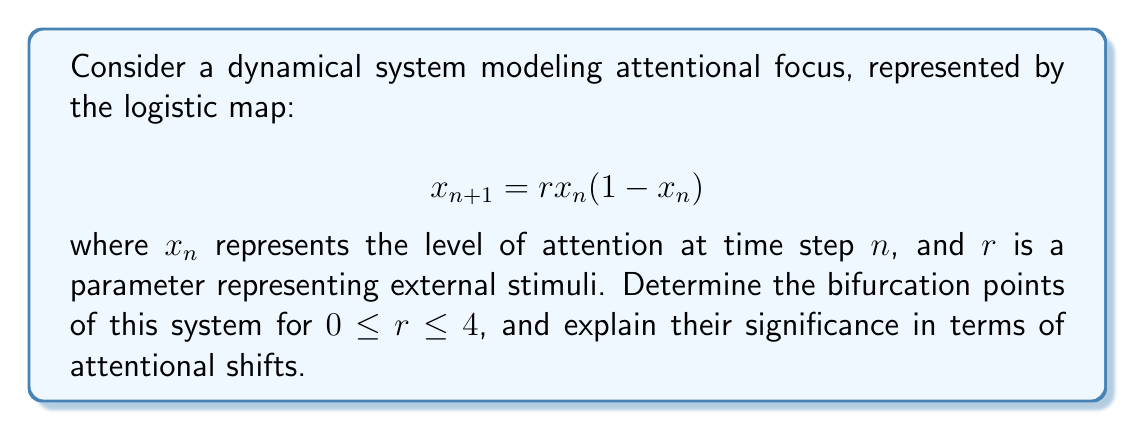Can you answer this question? To find the bifurcation points, we need to analyze the stability of the fixed points and their period-doubling behavior:

1. Find the fixed points:
   Set $x_{n+1} = x_n = x^*$
   $$ x^* = rx^*(1-x^*) $$
   Solving this equation gives two fixed points:
   $$ x^*_1 = 0 \text{ and } x^*_2 = 1 - \frac{1}{r} $$

2. Analyze stability of $x^*_1 = 0$:
   Calculate the derivative of the map at $x^*_1$:
   $$ f'(x) = r(1-2x) $$
   $$ f'(0) = r $$
   The fixed point is stable when $|f'(0)| < 1$, i.e., when $-1 < r < 1$
   The first bifurcation occurs at $r = 1$

3. Analyze stability of $x^*_2 = 1 - \frac{1}{r}$:
   $$ f'(1-\frac{1}{r}) = 2-r $$
   This fixed point is stable when $|2-r| < 1$, i.e., when $1 < r < 3$
   The second bifurcation occurs at $r = 3$

4. Period-doubling bifurcations:
   After $r = 3$, the system undergoes a series of period-doubling bifurcations.
   The onset of chaos occurs at approximately $r \approx 3.57$, known as the Feigenbaum point.

Significance for attentional shifts:
- $r < 1$: Attention converges to zero (complete inattention)
- $1 < r < 3$: Stable attention at a non-zero level
- $3 < r < 3.57$: Oscillating attention levels (periodic behavior)
- $r > 3.57$: Chaotic fluctuations in attention (unpredictable shifts)
Answer: Bifurcation points: $r = 1$, $r = 3$, and $r \approx 3.57$ (Feigenbaum point) 